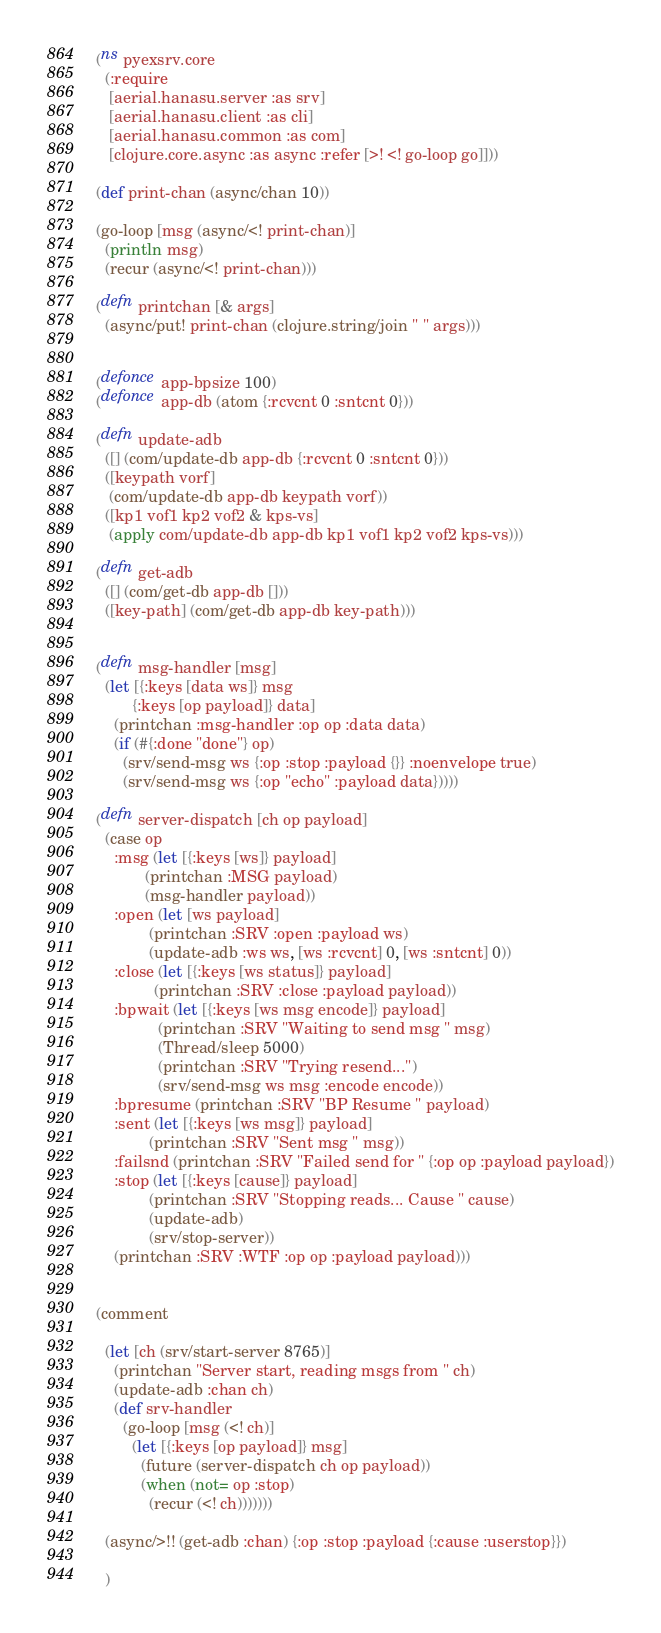Convert code to text. <code><loc_0><loc_0><loc_500><loc_500><_Clojure_>(ns pyexsrv.core
  (:require
   [aerial.hanasu.server :as srv]
   [aerial.hanasu.client :as cli]
   [aerial.hanasu.common :as com]
   [clojure.core.async :as async :refer [>! <! go-loop go]]))

(def print-chan (async/chan 10))

(go-loop [msg (async/<! print-chan)]
  (println msg)
  (recur (async/<! print-chan)))

(defn printchan [& args]
  (async/put! print-chan (clojure.string/join " " args)))


(defonce app-bpsize 100)
(defonce app-db (atom {:rcvcnt 0 :sntcnt 0}))

(defn update-adb
  ([] (com/update-db app-db {:rcvcnt 0 :sntcnt 0}))
  ([keypath vorf]
   (com/update-db app-db keypath vorf))
  ([kp1 vof1 kp2 vof2 & kps-vs]
   (apply com/update-db app-db kp1 vof1 kp2 vof2 kps-vs)))

(defn get-adb
  ([] (com/get-db app-db []))
  ([key-path] (com/get-db app-db key-path)))


(defn msg-handler [msg]
  (let [{:keys [data ws]} msg
        {:keys [op payload]} data]
    (printchan :msg-handler :op op :data data)
    (if (#{:done "done"} op)
      (srv/send-msg ws {:op :stop :payload {}} :noenvelope true)
      (srv/send-msg ws {:op "echo" :payload data}))))

(defn server-dispatch [ch op payload]
  (case op
    :msg (let [{:keys [ws]} payload]
           (printchan :MSG payload)
           (msg-handler payload))
    :open (let [ws payload]
            (printchan :SRV :open :payload ws)
            (update-adb :ws ws, [ws :rcvcnt] 0, [ws :sntcnt] 0))
    :close (let [{:keys [ws status]} payload]
             (printchan :SRV :close :payload payload))
    :bpwait (let [{:keys [ws msg encode]} payload]
              (printchan :SRV "Waiting to send msg " msg)
              (Thread/sleep 5000)
              (printchan :SRV "Trying resend...")
              (srv/send-msg ws msg :encode encode))
    :bpresume (printchan :SRV "BP Resume " payload)
    :sent (let [{:keys [ws msg]} payload]
            (printchan :SRV "Sent msg " msg))
    :failsnd (printchan :SRV "Failed send for " {:op op :payload payload})
    :stop (let [{:keys [cause]} payload]
            (printchan :SRV "Stopping reads... Cause " cause)
            (update-adb)
            (srv/stop-server))
    (printchan :SRV :WTF :op op :payload payload)))


(comment

  (let [ch (srv/start-server 8765)]
    (printchan "Server start, reading msgs from " ch)
    (update-adb :chan ch)
    (def srv-handler
      (go-loop [msg (<! ch)]
        (let [{:keys [op payload]} msg]
          (future (server-dispatch ch op payload))
          (when (not= op :stop)
            (recur (<! ch)))))))

  (async/>!! (get-adb :chan) {:op :stop :payload {:cause :userstop}})

  )
</code> 